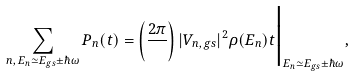<formula> <loc_0><loc_0><loc_500><loc_500>\sum _ { n , \, E _ { n } \simeq E _ { g s } \pm \hbar { \omega } } P _ { n } ( t ) = \left ( \frac { 2 \pi } { } \right ) | V _ { n , \, g s } | ^ { 2 } \rho ( E _ { n } ) t \Big | _ { { E _ { n } } \simeq E _ { g s } \pm \hbar { \omega } } ,</formula> 